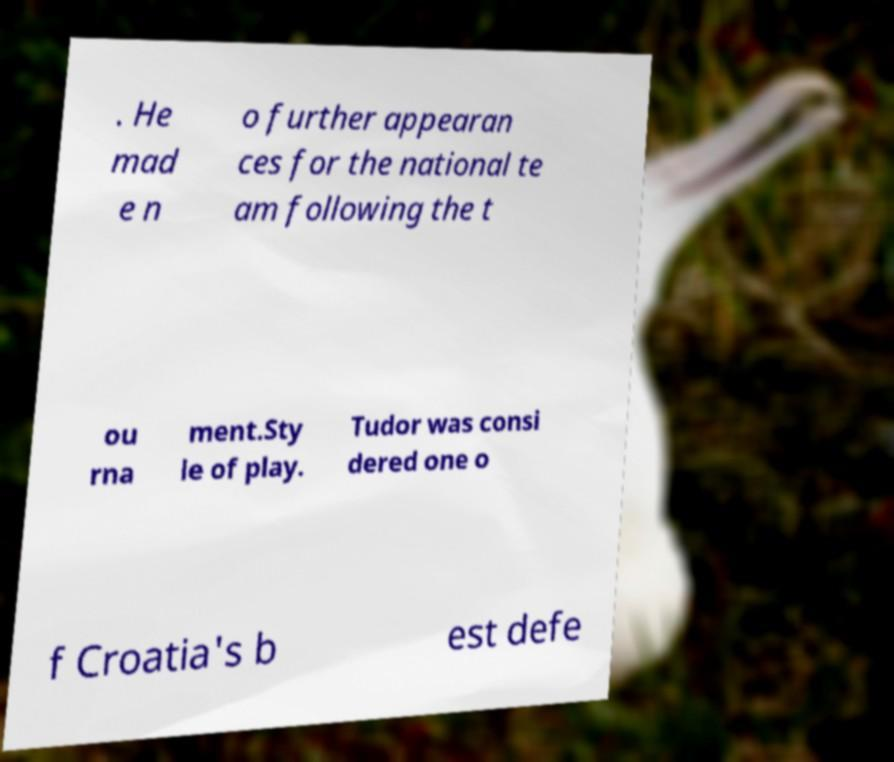Can you read and provide the text displayed in the image?This photo seems to have some interesting text. Can you extract and type it out for me? . He mad e n o further appearan ces for the national te am following the t ou rna ment.Sty le of play. Tudor was consi dered one o f Croatia's b est defe 